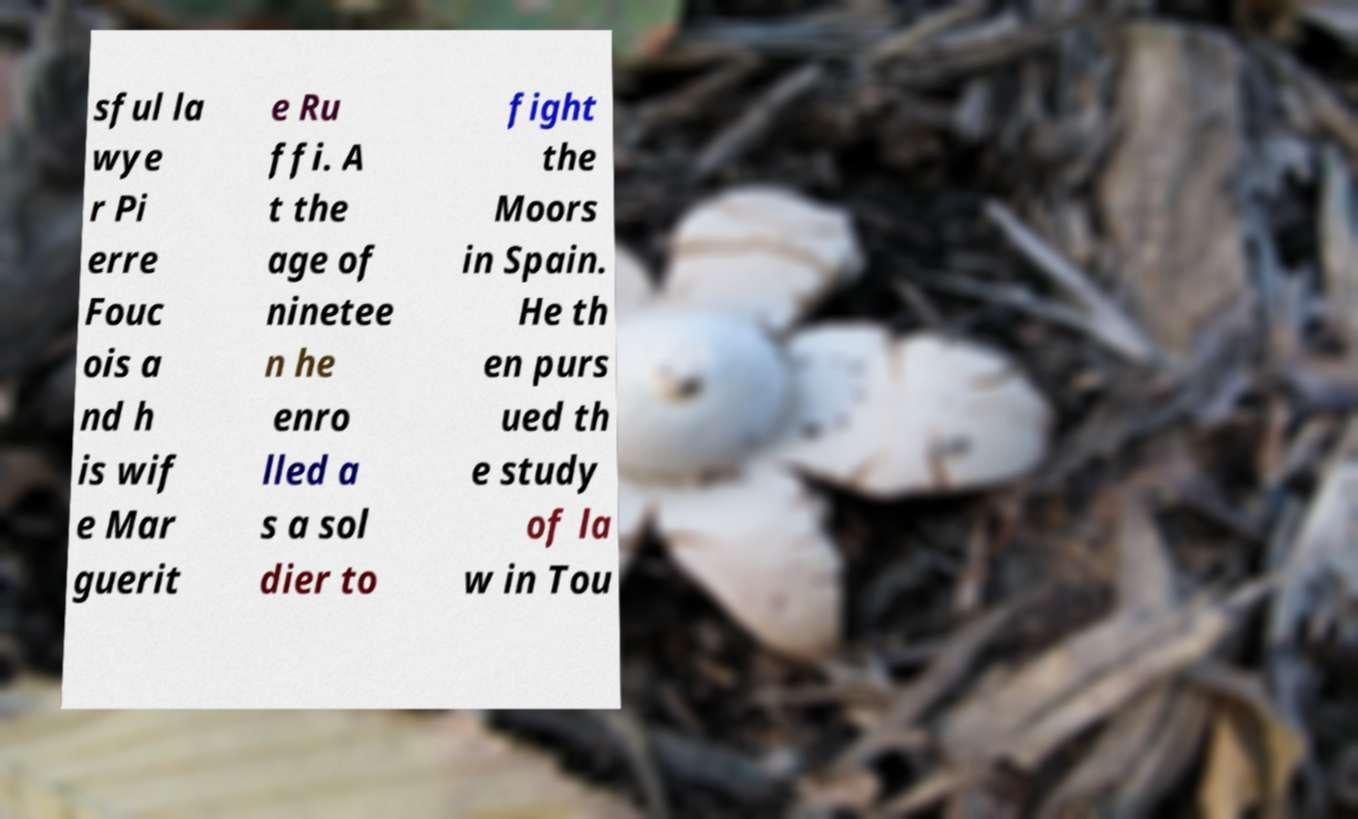I need the written content from this picture converted into text. Can you do that? sful la wye r Pi erre Fouc ois a nd h is wif e Mar guerit e Ru ffi. A t the age of ninetee n he enro lled a s a sol dier to fight the Moors in Spain. He th en purs ued th e study of la w in Tou 